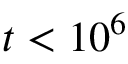<formula> <loc_0><loc_0><loc_500><loc_500>t < 1 0 ^ { 6 }</formula> 